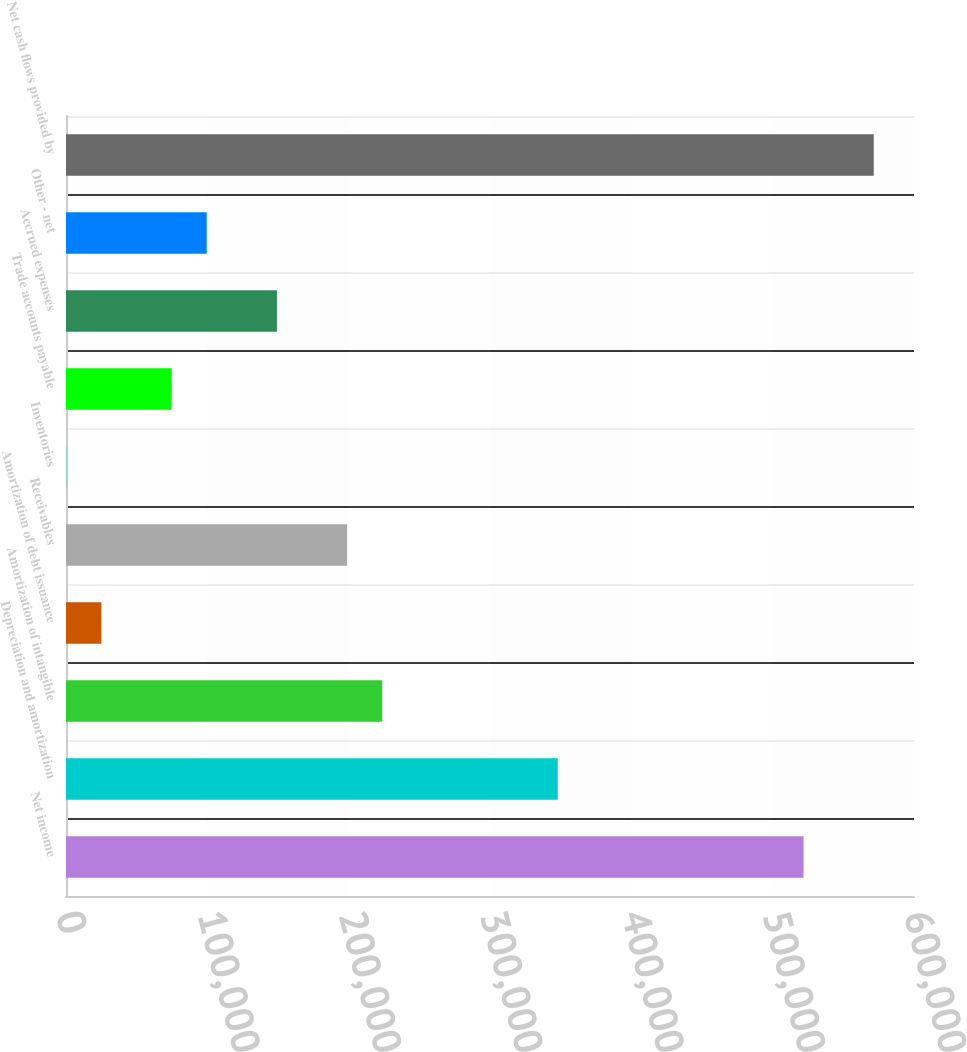<chart> <loc_0><loc_0><loc_500><loc_500><bar_chart><fcel>Net income<fcel>Depreciation and amortization<fcel>Amortization of intangible<fcel>Amortization of debt issuance<fcel>Receivables<fcel>Inventories<fcel>Trade accounts payable<fcel>Accrued expenses<fcel>Other - net<fcel>Net cash flows provided by<nl><fcel>521842<fcel>347958<fcel>223756<fcel>25031.5<fcel>198915<fcel>191<fcel>74712.5<fcel>149234<fcel>99553<fcel>571522<nl></chart> 